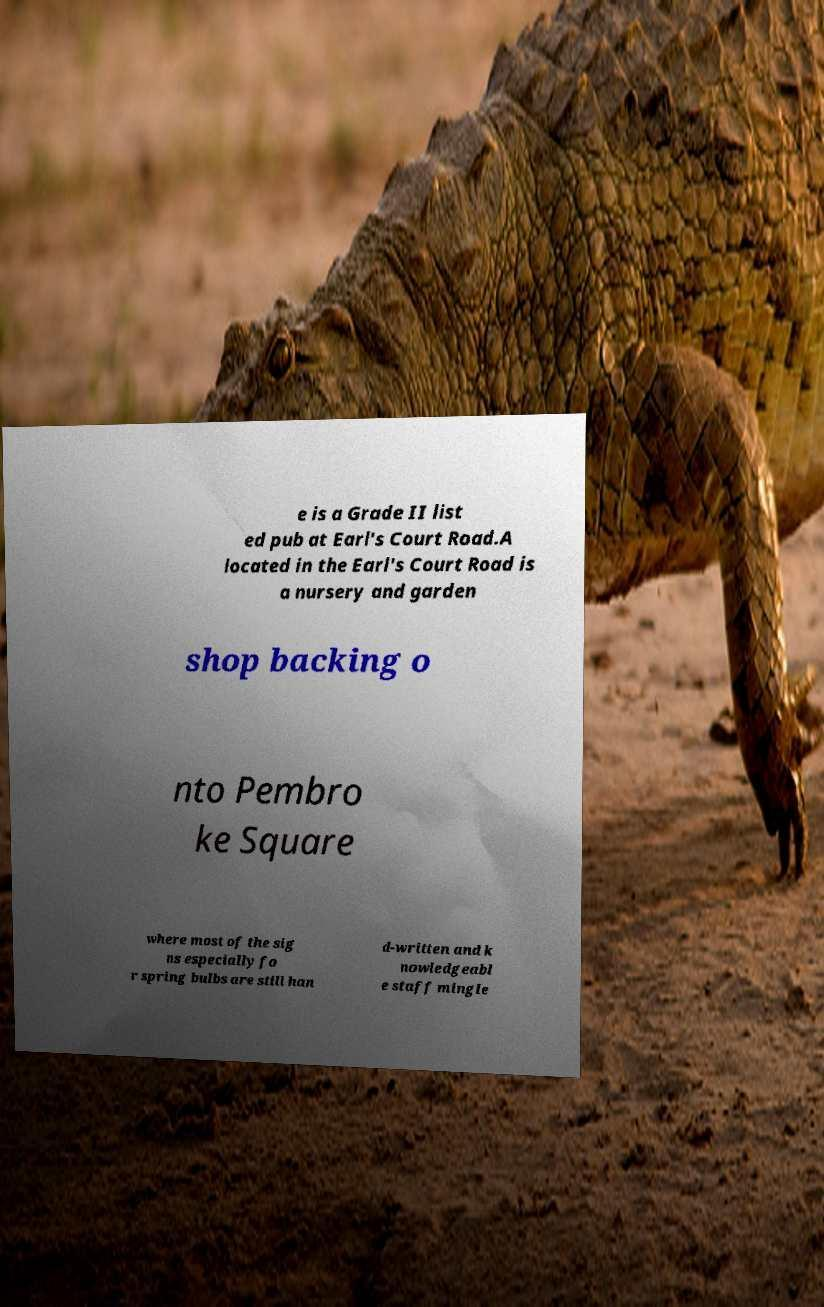For documentation purposes, I need the text within this image transcribed. Could you provide that? e is a Grade II list ed pub at Earl's Court Road.A located in the Earl's Court Road is a nursery and garden shop backing o nto Pembro ke Square where most of the sig ns especially fo r spring bulbs are still han d-written and k nowledgeabl e staff mingle 